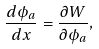Convert formula to latex. <formula><loc_0><loc_0><loc_500><loc_500>\frac { d \phi _ { a } } { d x } = \frac { \partial W } { \partial \phi _ { a } } ,</formula> 